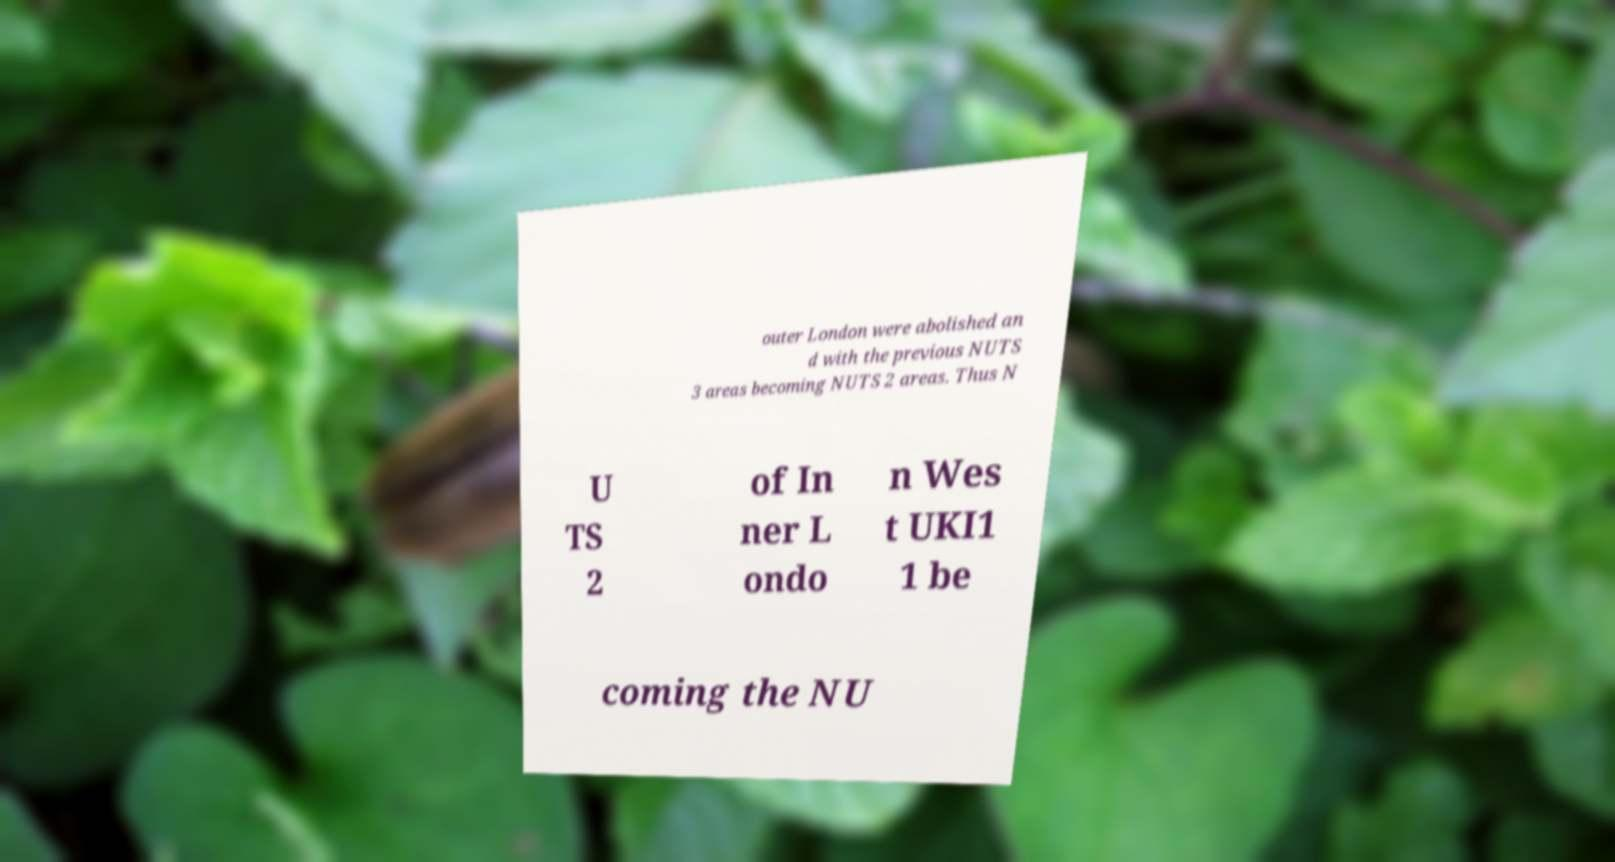What messages or text are displayed in this image? I need them in a readable, typed format. outer London were abolished an d with the previous NUTS 3 areas becoming NUTS 2 areas. Thus N U TS 2 of In ner L ondo n Wes t UKI1 1 be coming the NU 